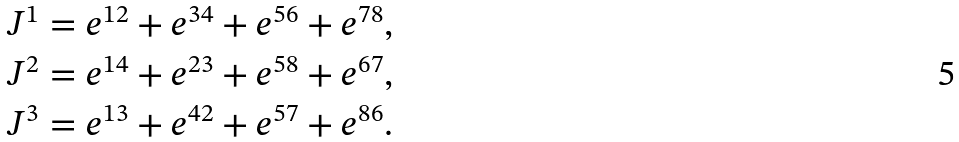<formula> <loc_0><loc_0><loc_500><loc_500>J ^ { 1 } & = e ^ { 1 2 } + e ^ { 3 4 } + e ^ { 5 6 } + e ^ { 7 8 } , \\ J ^ { 2 } & = e ^ { 1 4 } + e ^ { 2 3 } + e ^ { 5 8 } + e ^ { 6 7 } , \\ J ^ { 3 } & = e ^ { 1 3 } + e ^ { 4 2 } + e ^ { 5 7 } + e ^ { 8 6 } .</formula> 